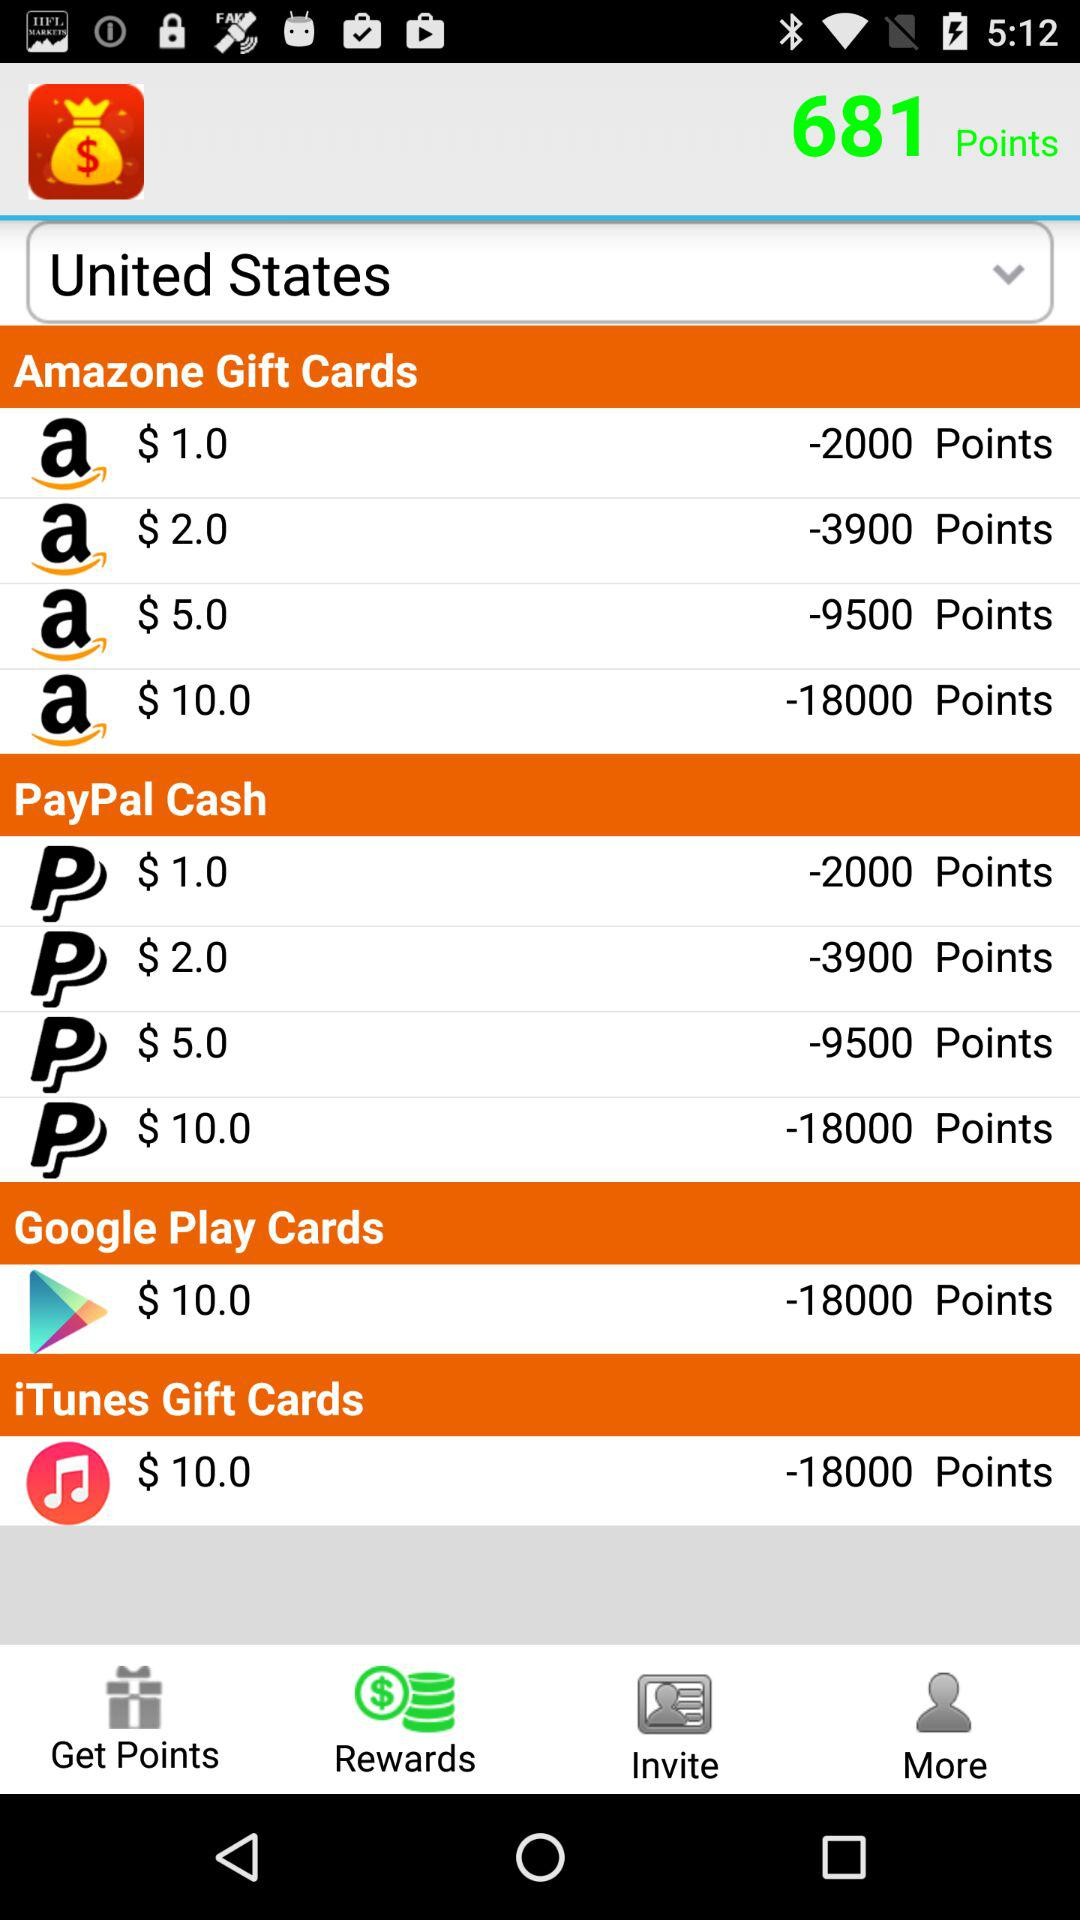What is the price of 2000 points in "Amazone Gift Cards"? The price of 2000 points in "Amazone Gift Cards" is $1. 